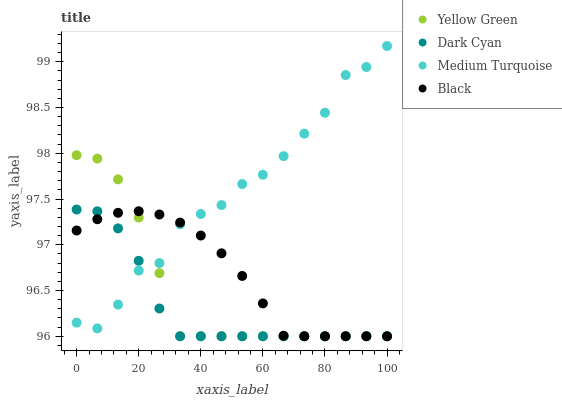Does Dark Cyan have the minimum area under the curve?
Answer yes or no. Yes. Does Medium Turquoise have the maximum area under the curve?
Answer yes or no. Yes. Does Black have the minimum area under the curve?
Answer yes or no. No. Does Black have the maximum area under the curve?
Answer yes or no. No. Is Black the smoothest?
Answer yes or no. Yes. Is Medium Turquoise the roughest?
Answer yes or no. Yes. Is Yellow Green the smoothest?
Answer yes or no. No. Is Yellow Green the roughest?
Answer yes or no. No. Does Dark Cyan have the lowest value?
Answer yes or no. Yes. Does Medium Turquoise have the lowest value?
Answer yes or no. No. Does Medium Turquoise have the highest value?
Answer yes or no. Yes. Does Yellow Green have the highest value?
Answer yes or no. No. Does Black intersect Medium Turquoise?
Answer yes or no. Yes. Is Black less than Medium Turquoise?
Answer yes or no. No. Is Black greater than Medium Turquoise?
Answer yes or no. No. 